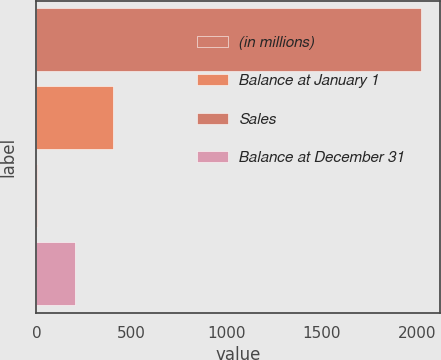<chart> <loc_0><loc_0><loc_500><loc_500><bar_chart><fcel>(in millions)<fcel>Balance at January 1<fcel>Sales<fcel>Balance at December 31<nl><fcel>2017<fcel>405<fcel>2<fcel>203.5<nl></chart> 